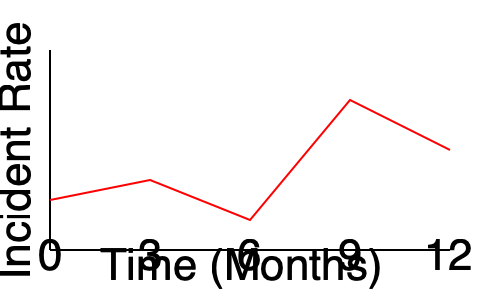Analyze the safety incident trend graph over a 12-month period. At which point does the graph indicate the most significant improvement in safety performance, and what could be a potential explanation for this change? To answer this question, we need to analyze the graph step-by-step:

1. The graph shows the incident rate over a 12-month period.
2. A lower incident rate indicates better safety performance.
3. We need to identify where the line shows the steepest downward slope, as this represents the most significant improvement.
4. Examining the graph:
   - From 0 to 3 months: Slight improvement
   - From 3 to 6 months: Worsening situation
   - From 6 to 9 months: Steep downward slope, indicating significant improvement
   - From 9 to 12 months: Slight worsening

5. The most significant improvement occurs between months 6 and 9.

6. Potential explanations for this improvement could include:
   - Implementation of new safety protocols or procedures
   - Increased safety training and awareness programs
   - Introduction of new safety equipment or technology
   - Successful identification and mitigation of major hazards
   - Improved management commitment to safety

7. As an EHS manager in construction, this improvement likely resulted from a combination of these factors, with a focus on proactive measures and increased emphasis on safety culture.
Answer: Between months 6 and 9, likely due to implementation of new safety measures and increased safety awareness. 